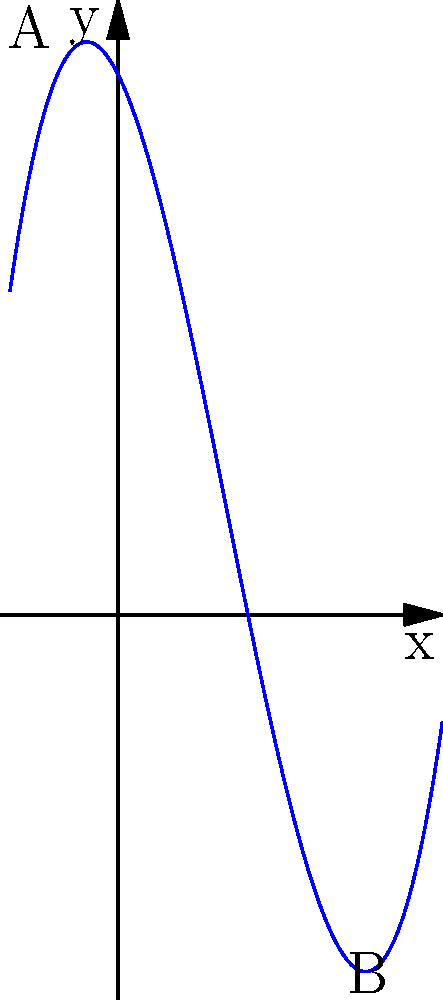The walking path in Cannon Hill Park follows a curve modeled by the polynomial function $f(x) = 0.25x^3 - 1.5x^2 - 2x + 10$, where $x$ is measured in hundreds of meters and $f(x)$ represents the elevation in meters. If you walk from point A to point B as shown on the graph, what is the total change in elevation? To find the change in elevation, we need to:

1. Identify the x-coordinates of points A and B:
   Point A: $x = -1$
   Point B: $x = 4$

2. Calculate the elevation at each point using the given function:

   For point A:
   $f(-1) = 0.25(-1)^3 - 1.5(-1)^2 - 2(-1) + 10$
   $= -0.25 - 1.5 + 2 + 10 = 10.25$ meters

   For point B:
   $f(4) = 0.25(4)^3 - 1.5(4)^2 - 2(4) + 10$
   $= 16 - 24 - 8 + 10 = -6$ meters

3. Calculate the change in elevation:
   Change = Elevation at B - Elevation at A
   $= -6 - 10.25 = -16.25$ meters

The negative value indicates a decrease in elevation.
Answer: $-16.25$ meters 